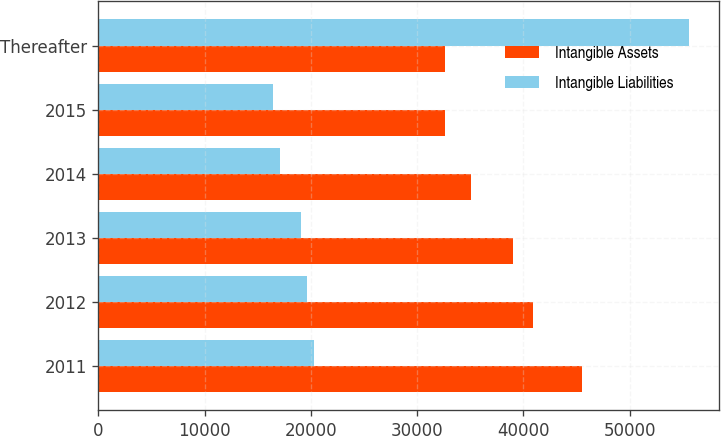Convert chart to OTSL. <chart><loc_0><loc_0><loc_500><loc_500><stacked_bar_chart><ecel><fcel>2011<fcel>2012<fcel>2013<fcel>2014<fcel>2015<fcel>Thereafter<nl><fcel>Intangible Assets<fcel>45502<fcel>40878<fcel>39055<fcel>35083<fcel>32584<fcel>32584<nl><fcel>Intangible Liabilities<fcel>20316<fcel>19618<fcel>19085<fcel>17065<fcel>16392<fcel>55596<nl></chart> 